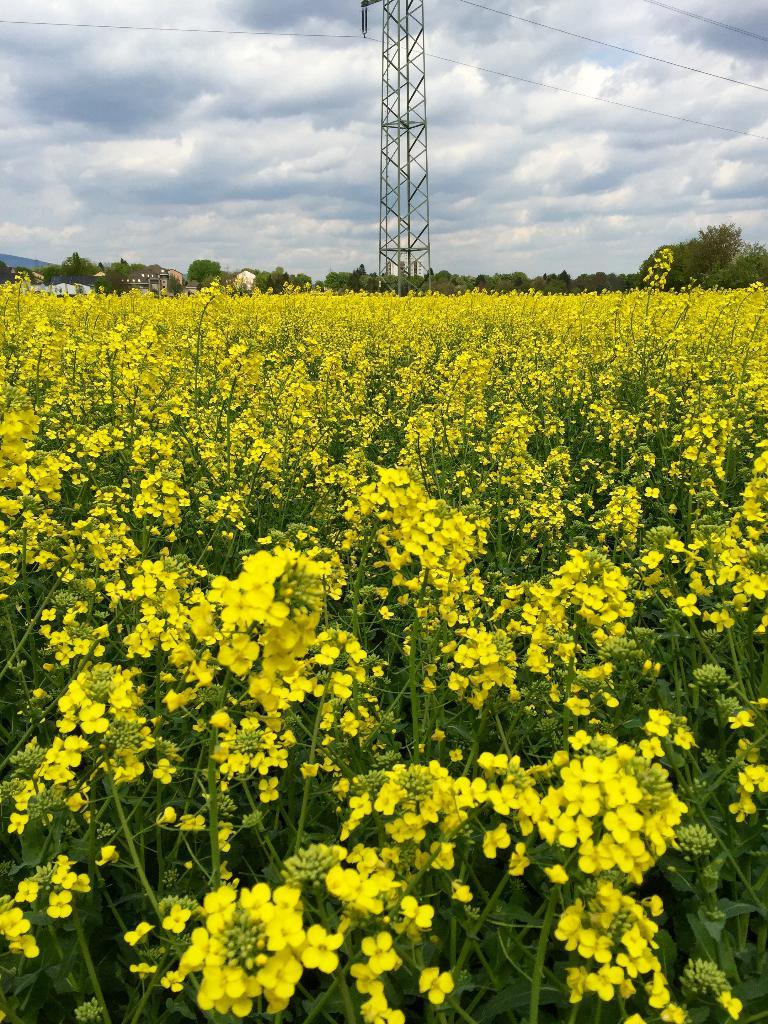What types of vegetation can be seen in the image? There are plants and flowers in the image. What is the main structure in the center of the image? There is a tower in the center of the image. What can be seen in the background of the image? There are trees, buildings, mountains, and the sky visible in the background of the image. How many boats are visible in the image? There are no boats present in the image. What type of currency is being exchanged in the image? There is no exchange of money or currency depicted in the image. 